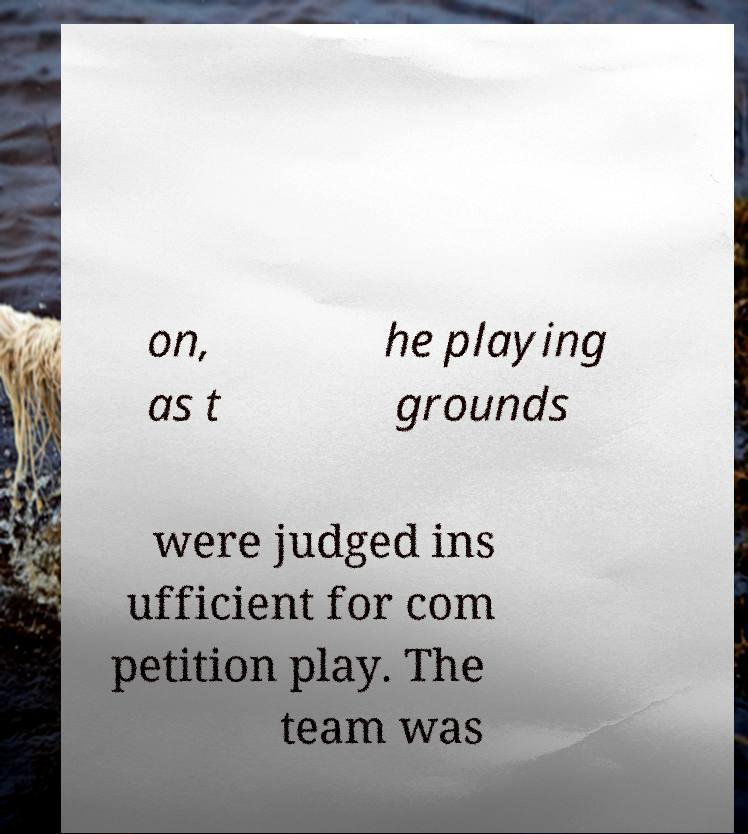What messages or text are displayed in this image? I need them in a readable, typed format. on, as t he playing grounds were judged ins ufficient for com petition play. The team was 